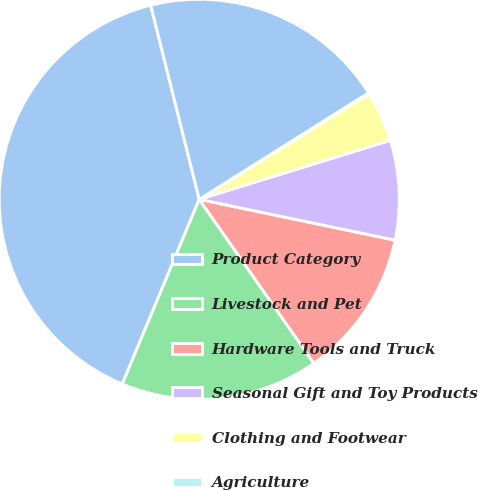<chart> <loc_0><loc_0><loc_500><loc_500><pie_chart><fcel>Product Category<fcel>Livestock and Pet<fcel>Hardware Tools and Truck<fcel>Seasonal Gift and Toy Products<fcel>Clothing and Footwear<fcel>Agriculture<fcel>Total<nl><fcel>39.82%<fcel>15.99%<fcel>12.02%<fcel>8.04%<fcel>4.07%<fcel>0.1%<fcel>19.96%<nl></chart> 